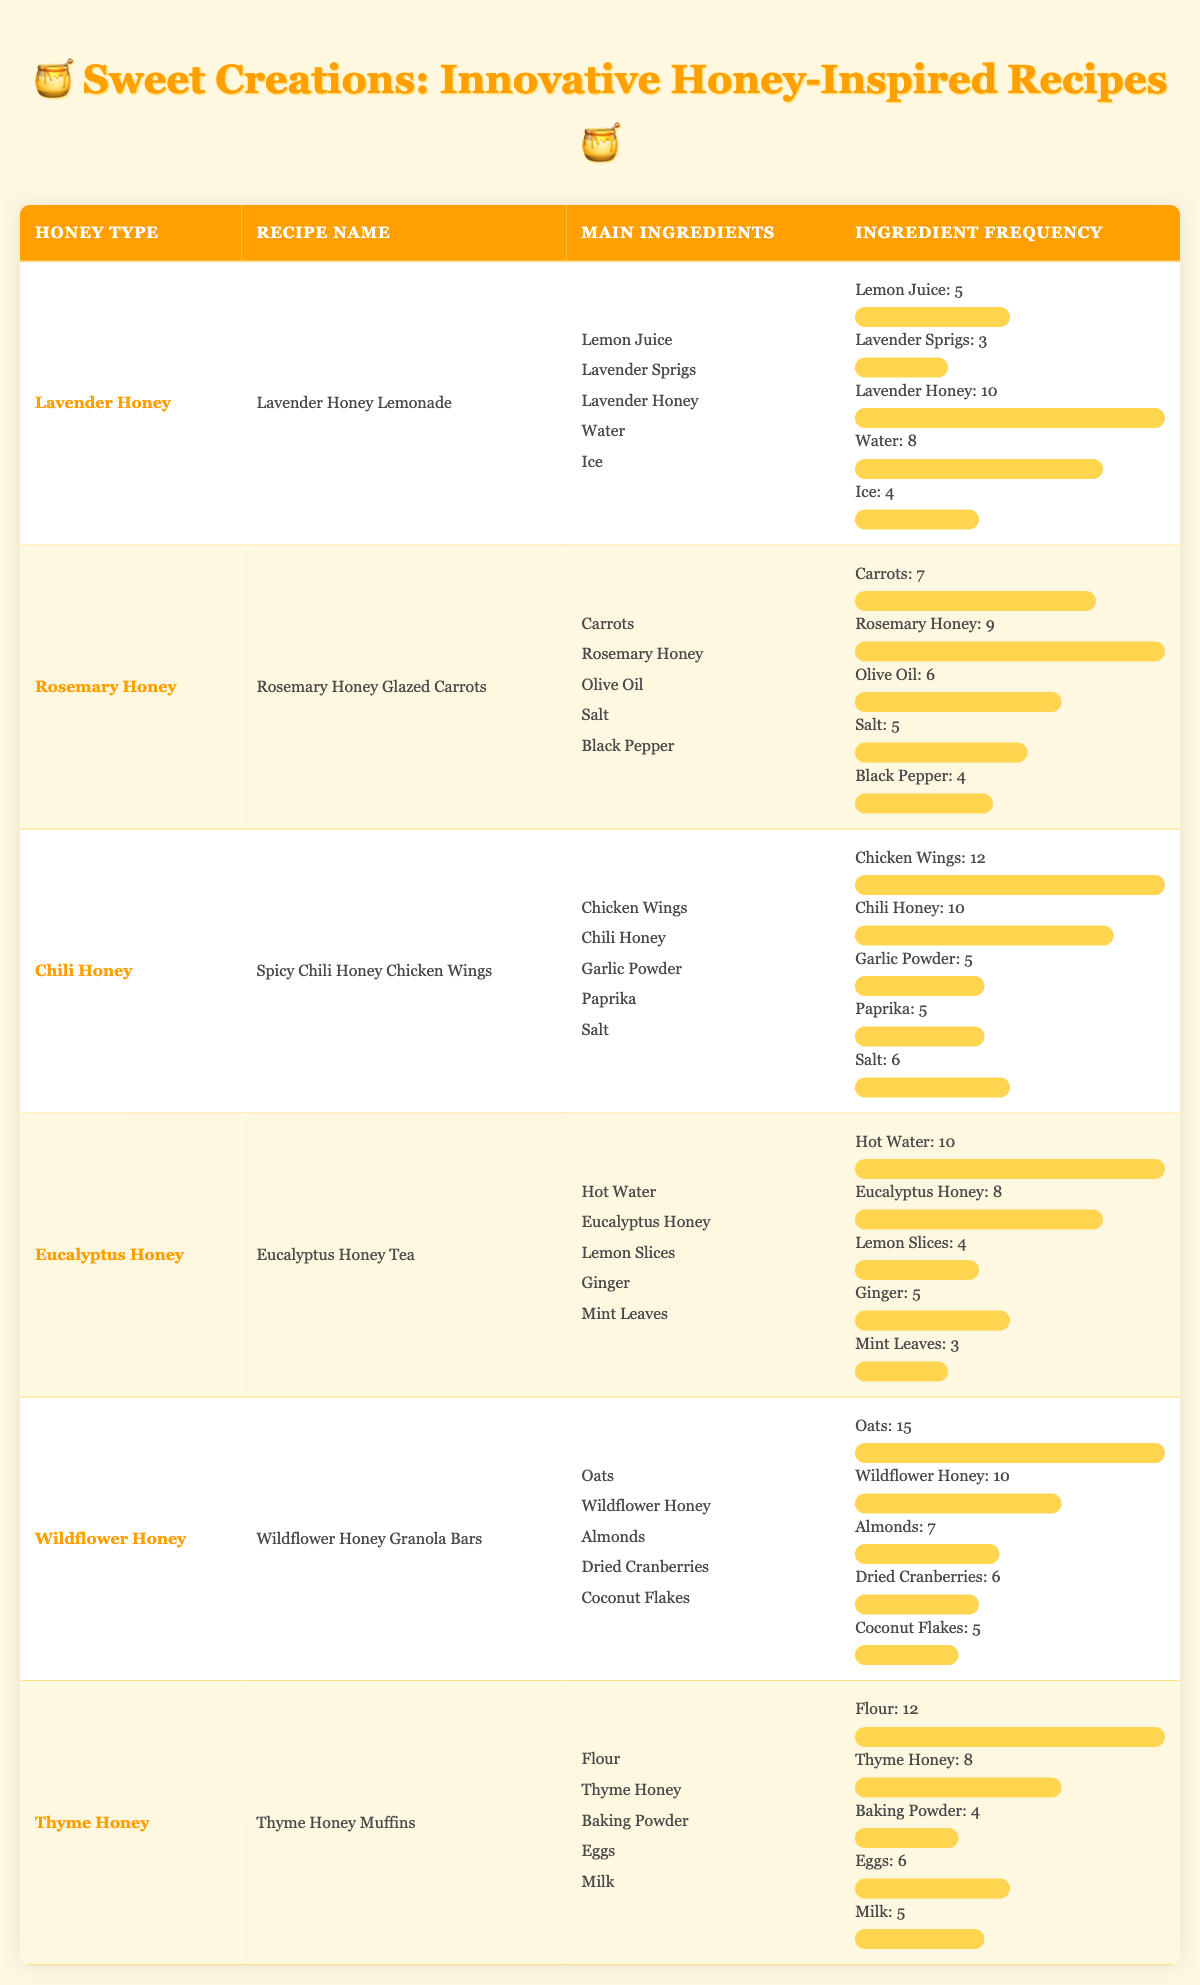What is the recipe that uses Chili Honey? The recipe for Chili Honey is "Spicy Chili Honey Chicken Wings" as identified in the table under the row for Chili Honey.
Answer: Spicy Chili Honey Chicken Wings Which recipe features Wildflower Honey? The recipe that features Wildflower Honey is "Wildflower Honey Granola Bars," shown in the respective row for Wildflower Honey.
Answer: Wildflower Honey Granola Bars How many main ingredients are used in the Lavender Honey recipe? The Lavender Honey recipe has 5 main ingredients listed under its section in the table: Lemon Juice, Lavender Sprigs, Lavender Honey, Water, and Ice.
Answer: 5 Which ingredient has the highest frequency in the Thyme Honey recipe? In the Thyme Honey recipe, Flour has the highest frequency at 12, compared to the other ingredients listed.
Answer: Flour What is the total ingredient frequency for the Eucalyptus Honey recipe? The total ingredient frequency is calculated by summing the frequencies: 10 (Hot Water) + 8 (Eucalyptus Honey) + 4 (Lemon Slices) + 5 (Ginger) + 3 (Mint Leaves) = 30.
Answer: 30 Is there a recipe that includes both Lavender Honey and Eucalyptus Honey? No, the table shows that each recipe is associated with only one type of honey. Lavender Honey is in "Lavender Honey Lemonade," and Eucalyptus Honey is in "Eucalyptus Honey Tea."
Answer: No Which recipe uses the most total ingredient frequency among the ones listed? For Chili Honey, the total ingredient frequency sums to 38 (12 + 10 + 5 + 5 + 6). This is higher than any other recipe, making it the recipe with the highest total frequency.
Answer: Spicy Chili Honey Chicken Wings How does the ingredient frequency of Oats in the Wildflower Honey recipe compare to that of Chicken Wings in the Chili Honey recipe? The frequency of Oats is 15 in the Wildflower Honey recipe, and Chicken Wings have a frequency of 12 in the Chili Honey recipe. Since 15 is greater than 12, Oats has a higher frequency.
Answer: Oats is higher What is the average frequency of ingredients for the Rosemary Honey recipe? The total frequency for Rosemary Honey is calculated as 7 (Carrots) + 9 (Rosemary Honey) + 6 (Olive Oil) + 5 (Salt) + 4 (Black Pepper) = 31. Since there are 5 ingredients, the average frequency is 31 / 5 = 6.2.
Answer: 6.2 Which honey type has the lowest total ingredient frequency? The total ingredient frequency for Eucalyptus Honey is 30, which is the lowest when compared to others like Lavender Honey (30) and Thyme Honey (35).
Answer: Eucalyptus Honey 